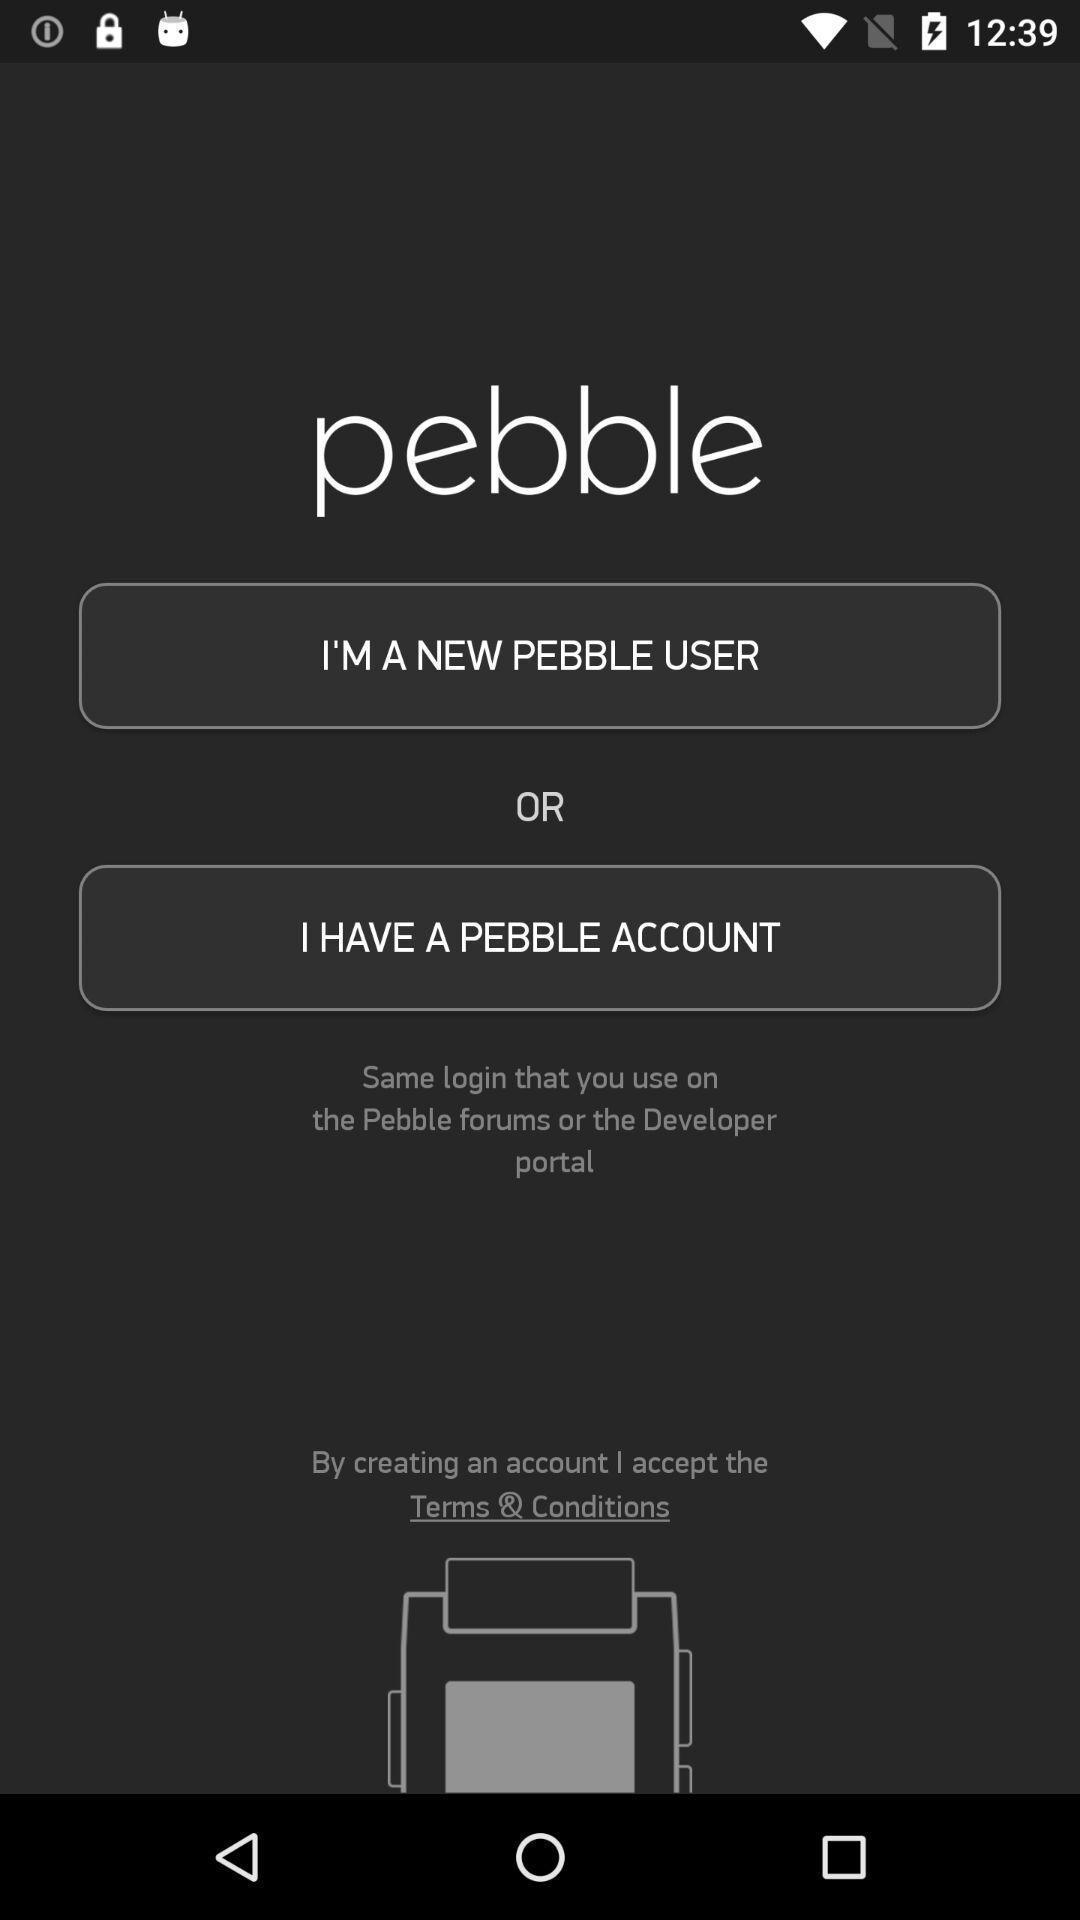Summarize the information in this screenshot. Screen displaying the login page. 